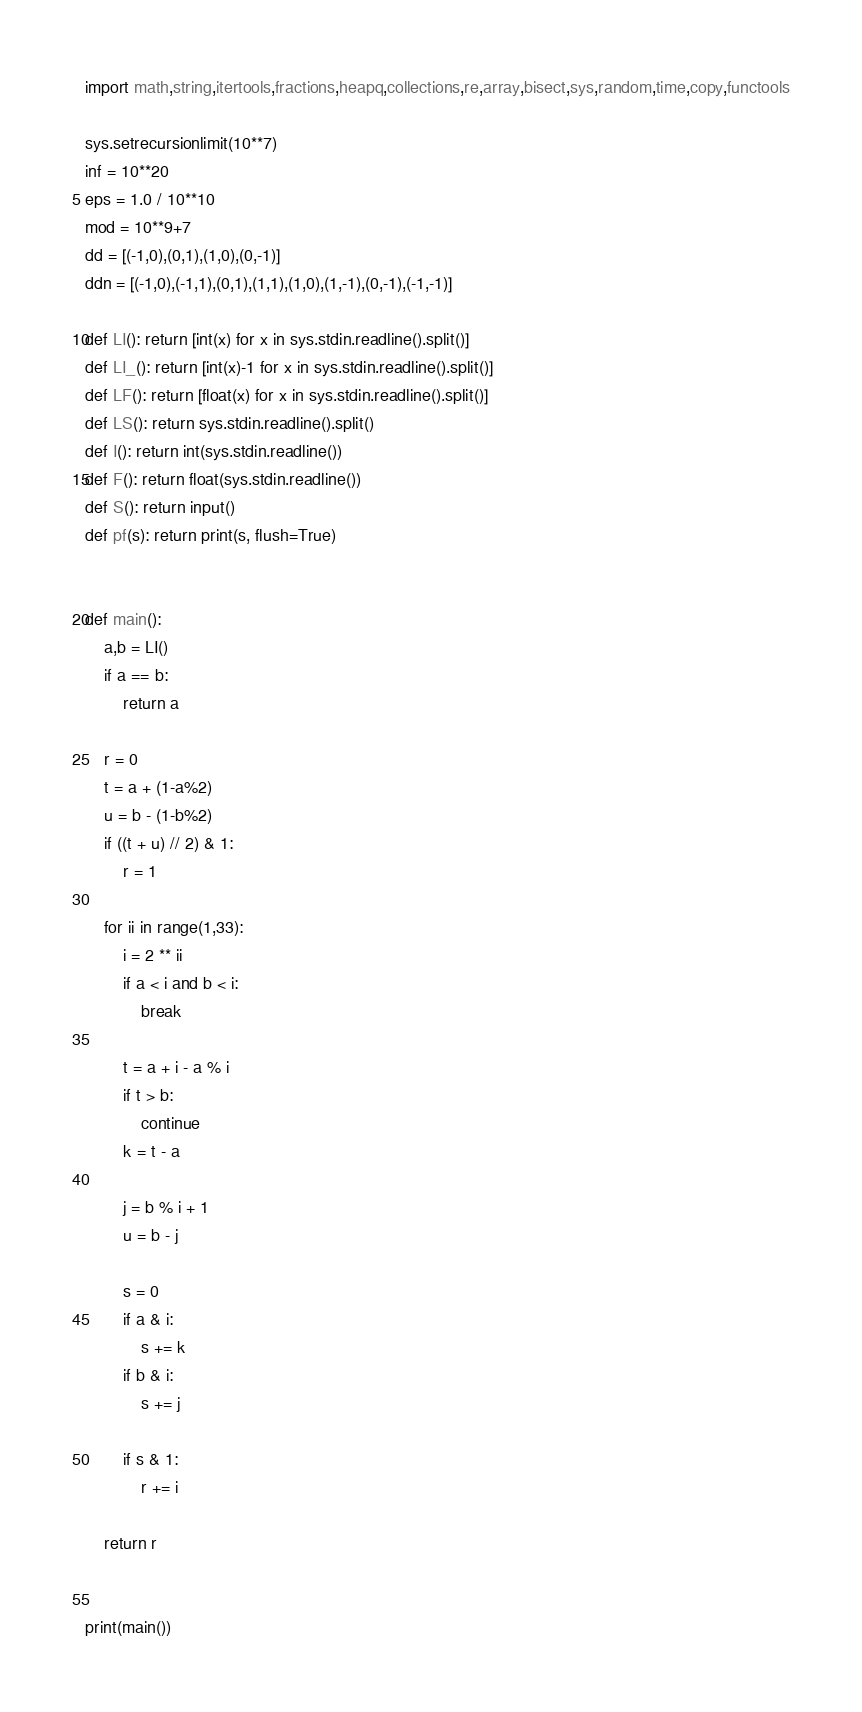Convert code to text. <code><loc_0><loc_0><loc_500><loc_500><_Python_>import math,string,itertools,fractions,heapq,collections,re,array,bisect,sys,random,time,copy,functools

sys.setrecursionlimit(10**7)
inf = 10**20
eps = 1.0 / 10**10
mod = 10**9+7
dd = [(-1,0),(0,1),(1,0),(0,-1)]
ddn = [(-1,0),(-1,1),(0,1),(1,1),(1,0),(1,-1),(0,-1),(-1,-1)]

def LI(): return [int(x) for x in sys.stdin.readline().split()]
def LI_(): return [int(x)-1 for x in sys.stdin.readline().split()]
def LF(): return [float(x) for x in sys.stdin.readline().split()]
def LS(): return sys.stdin.readline().split()
def I(): return int(sys.stdin.readline())
def F(): return float(sys.stdin.readline())
def S(): return input()
def pf(s): return print(s, flush=True)


def main():
    a,b = LI()
    if a == b:
        return a

    r = 0
    t = a + (1-a%2)
    u = b - (1-b%2)
    if ((t + u) // 2) & 1:
        r = 1

    for ii in range(1,33):
        i = 2 ** ii
        if a < i and b < i:
            break

        t = a + i - a % i
        if t > b:
            continue
        k = t - a

        j = b % i + 1
        u = b - j

        s = 0
        if a & i:
            s += k
        if b & i:
            s += j

        if s & 1:
            r += i

    return r


print(main())


</code> 